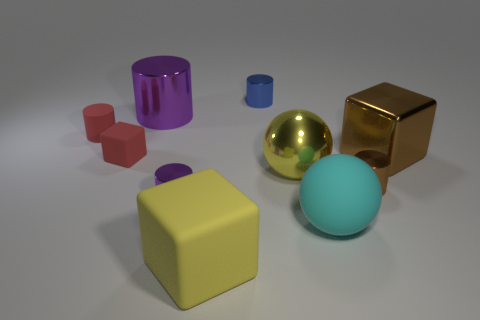Subtract all rubber cubes. How many cubes are left? 1 Subtract all blocks. How many objects are left? 7 Subtract all yellow spheres. How many spheres are left? 1 Subtract 1 balls. How many balls are left? 1 Subtract all cyan matte objects. Subtract all big metallic cubes. How many objects are left? 8 Add 7 small metal objects. How many small metal objects are left? 10 Add 8 large purple metallic objects. How many large purple metallic objects exist? 9 Subtract 1 red cubes. How many objects are left? 9 Subtract all blue cylinders. Subtract all gray balls. How many cylinders are left? 4 Subtract all cyan blocks. How many brown balls are left? 0 